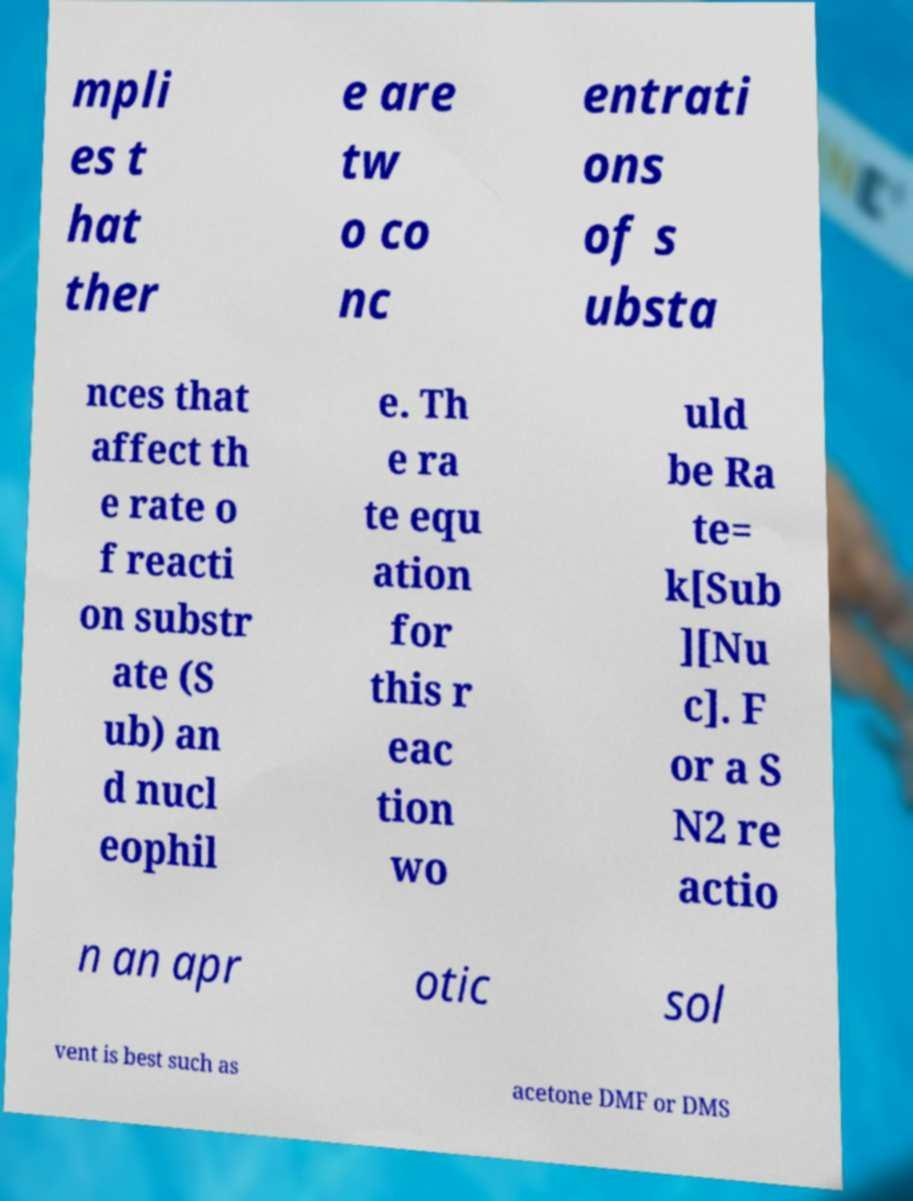I need the written content from this picture converted into text. Can you do that? mpli es t hat ther e are tw o co nc entrati ons of s ubsta nces that affect th e rate o f reacti on substr ate (S ub) an d nucl eophil e. Th e ra te equ ation for this r eac tion wo uld be Ra te= k[Sub ][Nu c]. F or a S N2 re actio n an apr otic sol vent is best such as acetone DMF or DMS 